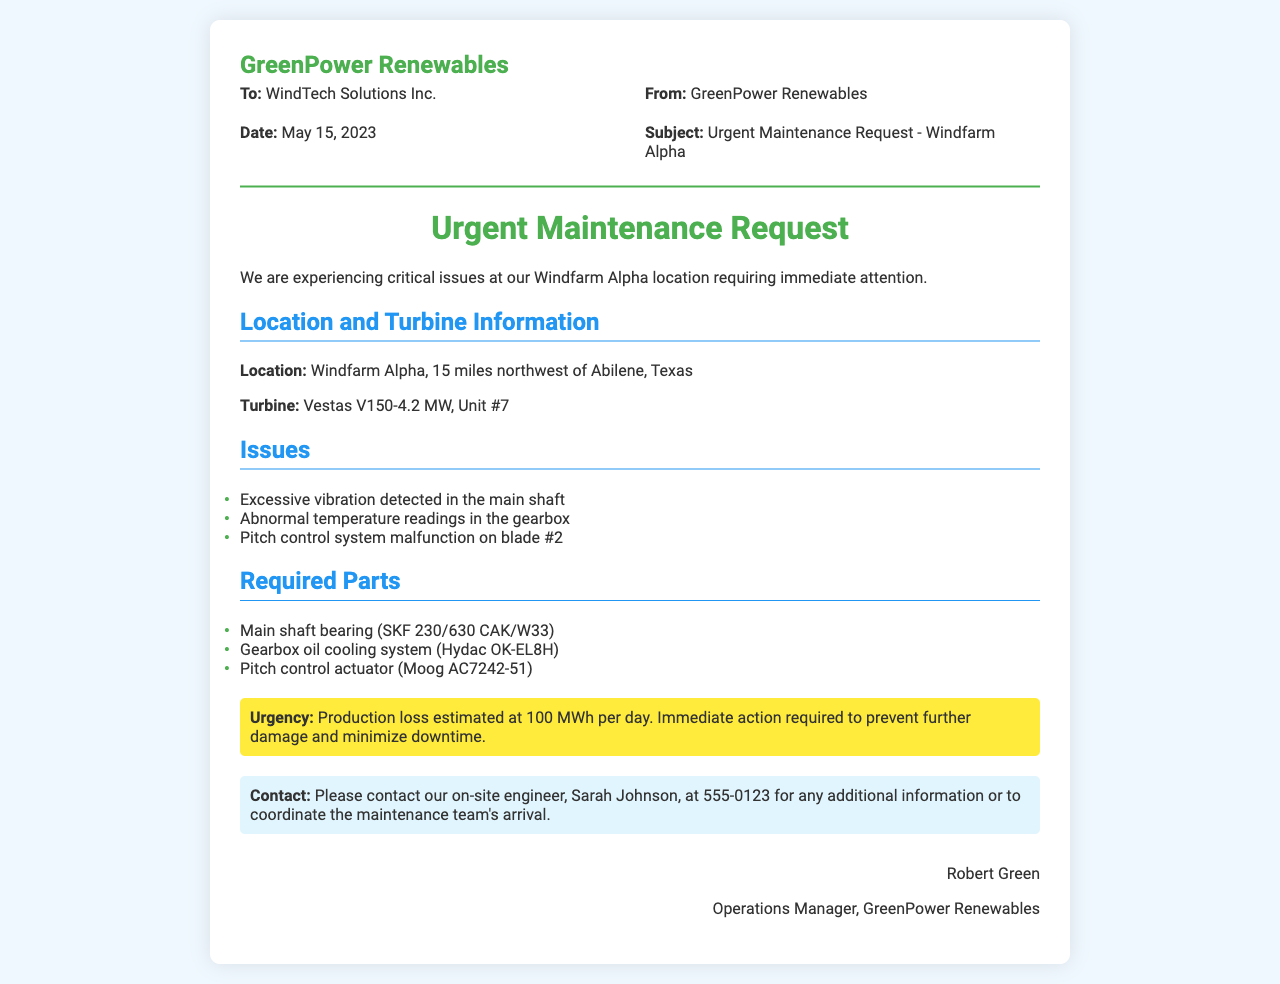what is the company requesting? The document is an urgent maintenance request regarding issues at Windfarm Alpha.
Answer: maintenance request who is the recipient of the fax? The fax is addressed to WindTech Solutions Inc.
Answer: WindTech Solutions Inc what is the date of the fax? The date specified in the document is May 15, 2023.
Answer: May 15, 2023 what turbine model is experiencing issues? The turbine model mentioned in the document is Vestas V150-4.2 MW.
Answer: Vestas V150-4.2 MW how many miles is Windfarm Alpha from Abilene, Texas? The document states that Windfarm Alpha is 15 miles northwest of Abilene, Texas.
Answer: 15 miles what is the estimated production loss per day? The document notes the production loss is estimated at 100 MWh per day.
Answer: 100 MWh what specific issue is noted with blade #2? The document indicates a malfunction in the pitch control system on blade #2.
Answer: pitch control system malfunction which part is required for the gearbox? A gearbox oil cooling system (Hydac OK-EL8H) is required as noted in the document.
Answer: Gearbox oil cooling system (Hydac OK-EL8H) who should be contacted for more information? The document instructs to contact on-site engineer Sarah Johnson for additional information.
Answer: Sarah Johnson what is the sender's position in the company? The sender is identified as the Operations Manager.
Answer: Operations Manager 